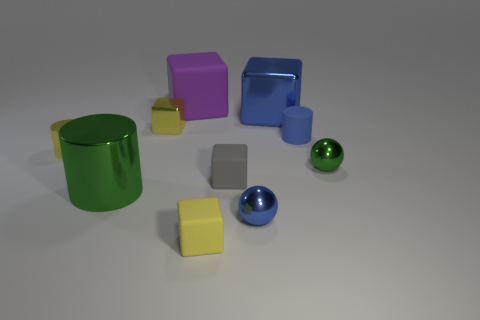Subtract all tiny yellow matte blocks. How many blocks are left? 4 Subtract all gray cubes. How many cubes are left? 4 Subtract all cyan blocks. Subtract all cyan cylinders. How many blocks are left? 5 Subtract all spheres. How many objects are left? 8 Subtract 0 green blocks. How many objects are left? 10 Subtract all purple matte cylinders. Subtract all small blue shiny spheres. How many objects are left? 9 Add 8 small blue rubber objects. How many small blue rubber objects are left? 9 Add 1 large green metallic cylinders. How many large green metallic cylinders exist? 2 